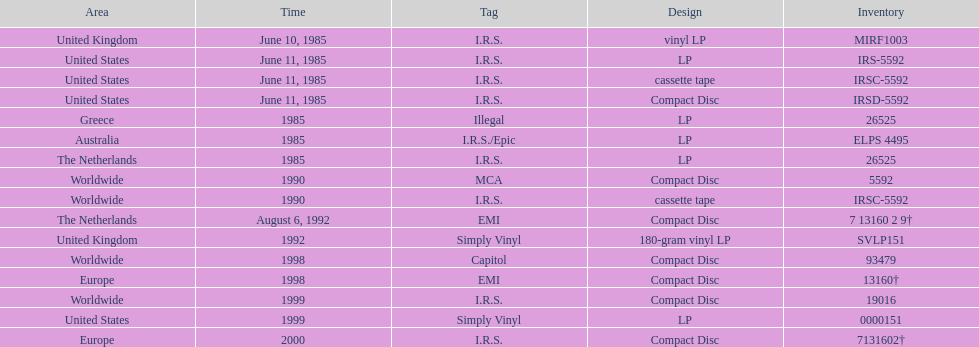Which is the only region with vinyl lp format? United Kingdom. 